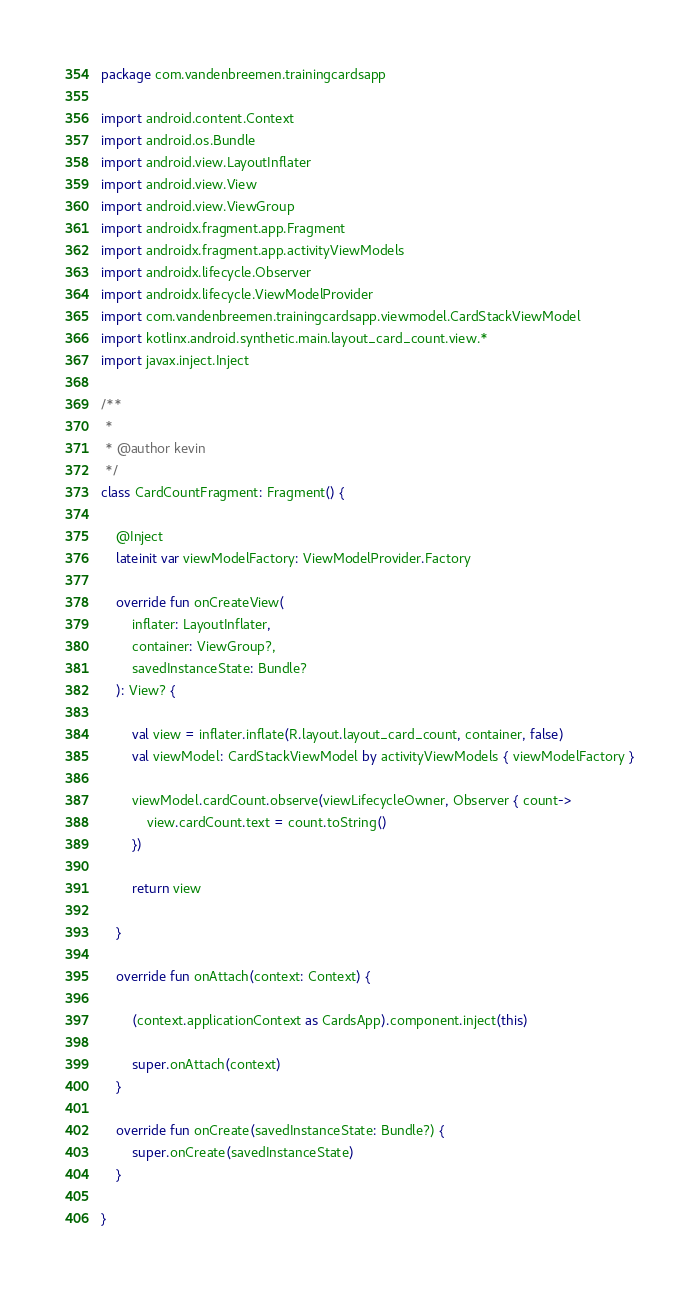<code> <loc_0><loc_0><loc_500><loc_500><_Kotlin_>package com.vandenbreemen.trainingcardsapp

import android.content.Context
import android.os.Bundle
import android.view.LayoutInflater
import android.view.View
import android.view.ViewGroup
import androidx.fragment.app.Fragment
import androidx.fragment.app.activityViewModels
import androidx.lifecycle.Observer
import androidx.lifecycle.ViewModelProvider
import com.vandenbreemen.trainingcardsapp.viewmodel.CardStackViewModel
import kotlinx.android.synthetic.main.layout_card_count.view.*
import javax.inject.Inject

/**
 *
 * @author kevin
 */
class CardCountFragment: Fragment() {

    @Inject
    lateinit var viewModelFactory: ViewModelProvider.Factory

    override fun onCreateView(
        inflater: LayoutInflater,
        container: ViewGroup?,
        savedInstanceState: Bundle?
    ): View? {

        val view = inflater.inflate(R.layout.layout_card_count, container, false)
        val viewModel: CardStackViewModel by activityViewModels { viewModelFactory }

        viewModel.cardCount.observe(viewLifecycleOwner, Observer { count->
            view.cardCount.text = count.toString()
        })

        return view

    }

    override fun onAttach(context: Context) {

        (context.applicationContext as CardsApp).component.inject(this)

        super.onAttach(context)
    }

    override fun onCreate(savedInstanceState: Bundle?) {
        super.onCreate(savedInstanceState)
    }

}</code> 